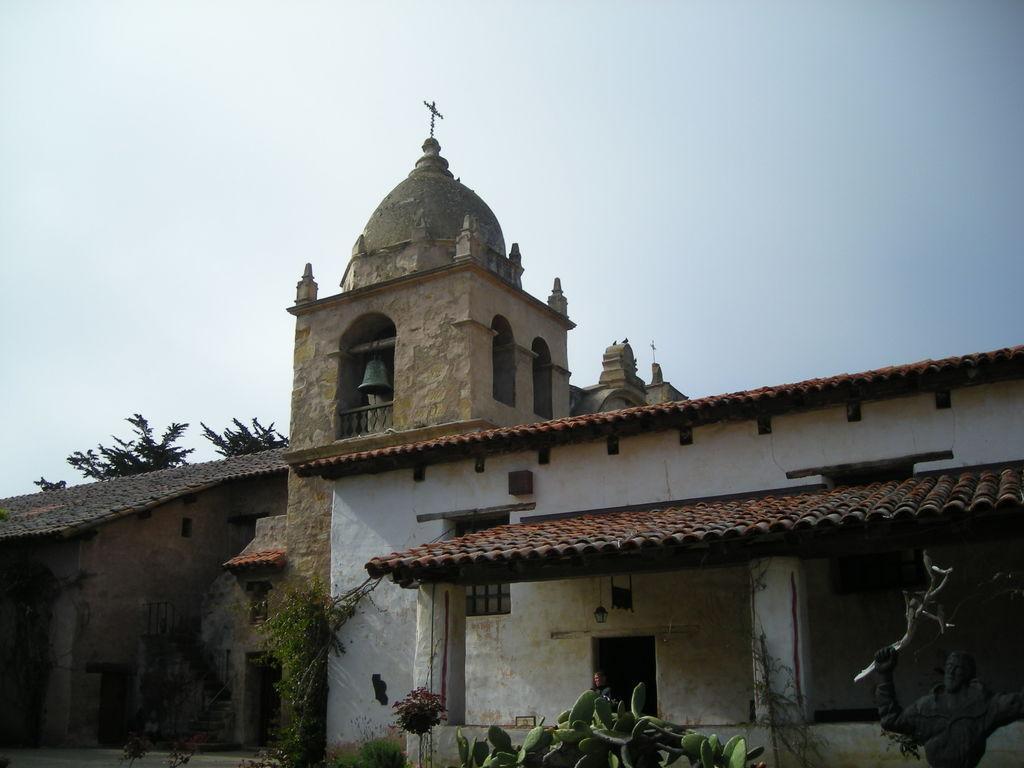In one or two sentences, can you explain what this image depicts? In this image there are few buildings, there is a cactus plant, trees, plants, a sculpture, two cross marks at the top of two buildings, two birds and a bell. 